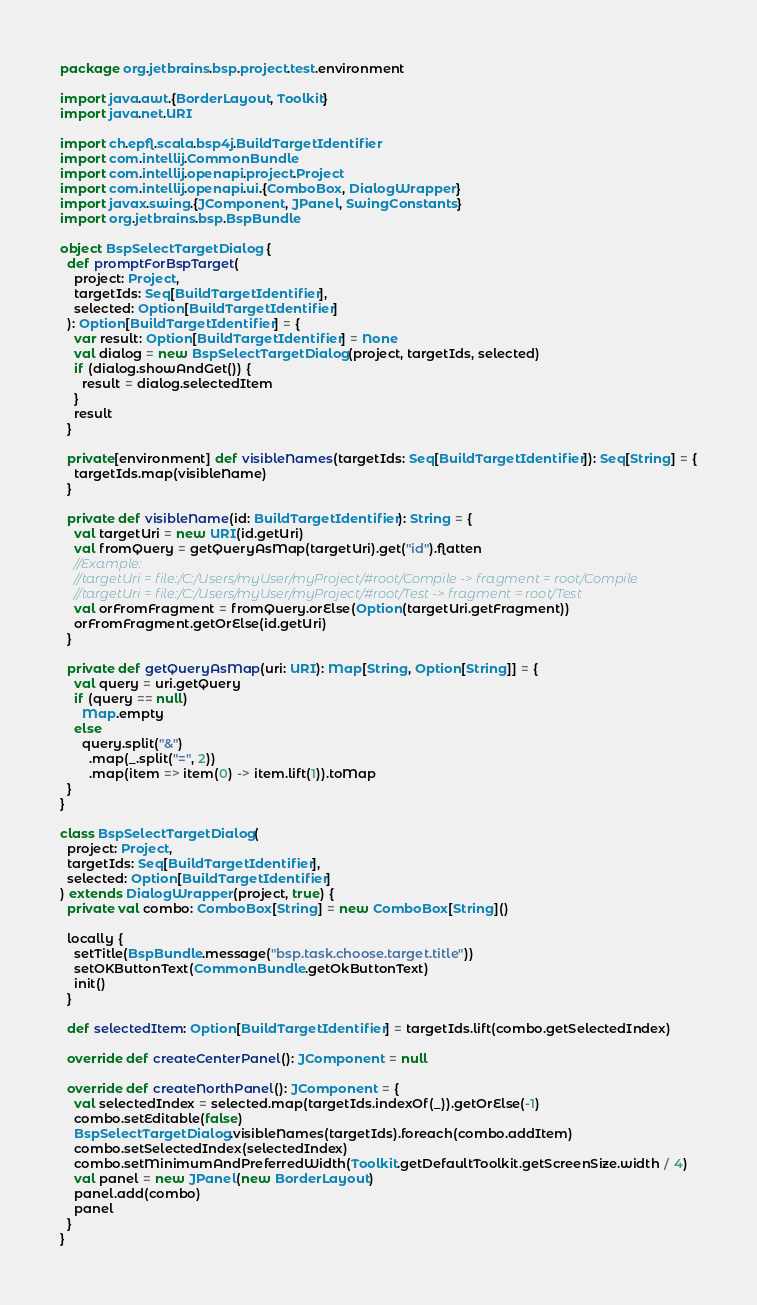<code> <loc_0><loc_0><loc_500><loc_500><_Scala_>package org.jetbrains.bsp.project.test.environment

import java.awt.{BorderLayout, Toolkit}
import java.net.URI

import ch.epfl.scala.bsp4j.BuildTargetIdentifier
import com.intellij.CommonBundle
import com.intellij.openapi.project.Project
import com.intellij.openapi.ui.{ComboBox, DialogWrapper}
import javax.swing.{JComponent, JPanel, SwingConstants}
import org.jetbrains.bsp.BspBundle

object BspSelectTargetDialog {
  def promptForBspTarget(
    project: Project,
    targetIds: Seq[BuildTargetIdentifier],
    selected: Option[BuildTargetIdentifier]
  ): Option[BuildTargetIdentifier] = {
    var result: Option[BuildTargetIdentifier] = None
    val dialog = new BspSelectTargetDialog(project, targetIds, selected)
    if (dialog.showAndGet()) {
      result = dialog.selectedItem
    }
    result
  }

  private[environment] def visibleNames(targetIds: Seq[BuildTargetIdentifier]): Seq[String] = {
    targetIds.map(visibleName)
  }

  private def visibleName(id: BuildTargetIdentifier): String = {
    val targetUri = new URI(id.getUri)
    val fromQuery = getQueryAsMap(targetUri).get("id").flatten
    //Example:
    //targetUri = file:/C:/Users/myUser/myProject/#root/Compile -> fragment = root/Compile
    //targetUri = file:/C:/Users/myUser/myProject/#root/Test -> fragment = root/Test
    val orFromFragment = fromQuery.orElse(Option(targetUri.getFragment))
    orFromFragment.getOrElse(id.getUri)
  }

  private def getQueryAsMap(uri: URI): Map[String, Option[String]] = {
    val query = uri.getQuery
    if (query == null)
      Map.empty
    else
      query.split("&")
        .map(_.split("=", 2))
        .map(item => item(0) -> item.lift(1)).toMap
  }
}

class BspSelectTargetDialog(
  project: Project,
  targetIds: Seq[BuildTargetIdentifier],
  selected: Option[BuildTargetIdentifier]
) extends DialogWrapper(project, true) {
  private val combo: ComboBox[String] = new ComboBox[String]()

  locally {
    setTitle(BspBundle.message("bsp.task.choose.target.title"))
    setOKButtonText(CommonBundle.getOkButtonText)
    init()
  }

  def selectedItem: Option[BuildTargetIdentifier] = targetIds.lift(combo.getSelectedIndex)

  override def createCenterPanel(): JComponent = null

  override def createNorthPanel(): JComponent = {
    val selectedIndex = selected.map(targetIds.indexOf(_)).getOrElse(-1)
    combo.setEditable(false)
    BspSelectTargetDialog.visibleNames(targetIds).foreach(combo.addItem)
    combo.setSelectedIndex(selectedIndex)
    combo.setMinimumAndPreferredWidth(Toolkit.getDefaultToolkit.getScreenSize.width / 4)
    val panel = new JPanel(new BorderLayout)
    panel.add(combo)
    panel
  }
}</code> 